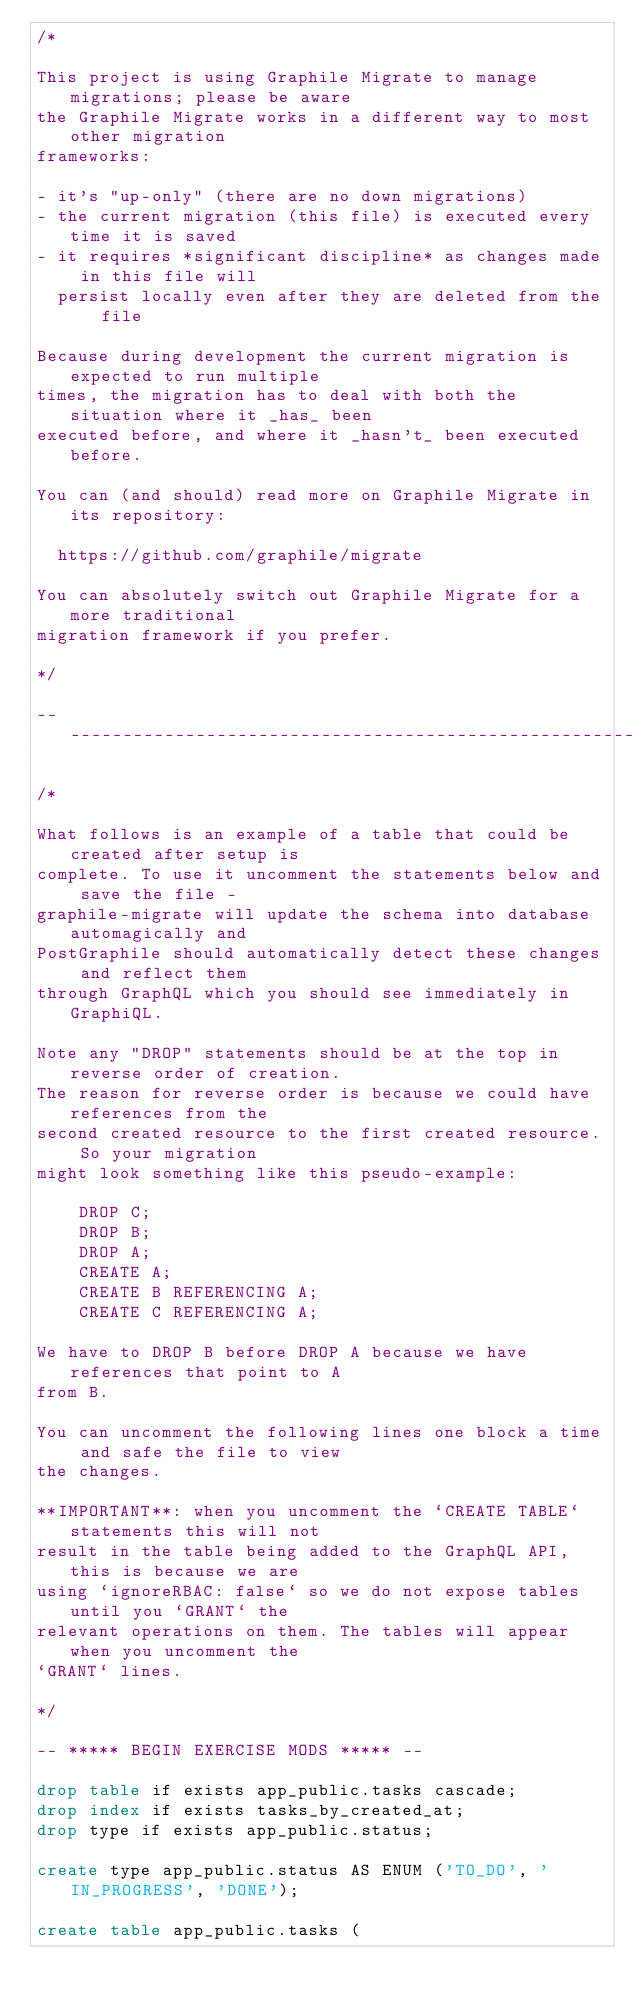Convert code to text. <code><loc_0><loc_0><loc_500><loc_500><_SQL_>/*

This project is using Graphile Migrate to manage migrations; please be aware
the Graphile Migrate works in a different way to most other migration
frameworks:

- it's "up-only" (there are no down migrations)
- the current migration (this file) is executed every time it is saved
- it requires *significant discipline* as changes made in this file will
  persist locally even after they are deleted from the file

Because during development the current migration is expected to run multiple
times, the migration has to deal with both the situation where it _has_ been
executed before, and where it _hasn't_ been executed before.

You can (and should) read more on Graphile Migrate in its repository:

  https://github.com/graphile/migrate

You can absolutely switch out Graphile Migrate for a more traditional
migration framework if you prefer.

*/

--------------------------------------------------------------------------------

/*

What follows is an example of a table that could be created after setup is
complete. To use it uncomment the statements below and save the file -
graphile-migrate will update the schema into database automagically and
PostGraphile should automatically detect these changes and reflect them
through GraphQL which you should see immediately in GraphiQL.

Note any "DROP" statements should be at the top in reverse order of creation.
The reason for reverse order is because we could have references from the
second created resource to the first created resource. So your migration
might look something like this pseudo-example:

    DROP C;
    DROP B;
    DROP A;
    CREATE A;
    CREATE B REFERENCING A;
    CREATE C REFERENCING A;

We have to DROP B before DROP A because we have references that point to A
from B.

You can uncomment the following lines one block a time and safe the file to view
the changes.

**IMPORTANT**: when you uncomment the `CREATE TABLE` statements this will not
result in the table being added to the GraphQL API, this is because we are
using `ignoreRBAC: false` so we do not expose tables until you `GRANT` the
relevant operations on them. The tables will appear when you uncomment the
`GRANT` lines.

*/

-- ***** BEGIN EXERCISE MODS ***** --

drop table if exists app_public.tasks cascade;
drop index if exists tasks_by_created_at;
drop type if exists app_public.status;

create type app_public.status AS ENUM ('TO_DO', 'IN_PROGRESS', 'DONE');

create table app_public.tasks (</code> 